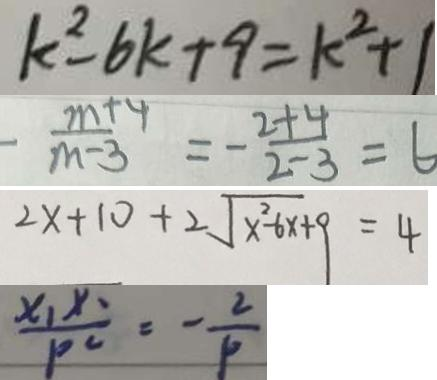Convert formula to latex. <formula><loc_0><loc_0><loc_500><loc_500>k ^ { 2 } - 6 k + 9 = k ^ { 2 } + 1 
 - \frac { m + 4 } { m - 3 } = - \frac { 2 + 4 } { 2 - 3 } = 6 
 2 x + 1 0 + 2 \sqrt { x ^ { 2 } - 6 x + 9 } = 4 
 \frac { x _ { 1 } x _ { 2 } } { P ^ { 2 } } = - \frac { 2 } { P }</formula> 